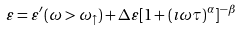Convert formula to latex. <formula><loc_0><loc_0><loc_500><loc_500>\varepsilon = \varepsilon ^ { \prime } ( \omega > { \omega } _ { \uparrow } ) + \Delta \varepsilon [ 1 + ( \imath \omega \tau ) ^ { \alpha } ] ^ { - \beta }</formula> 